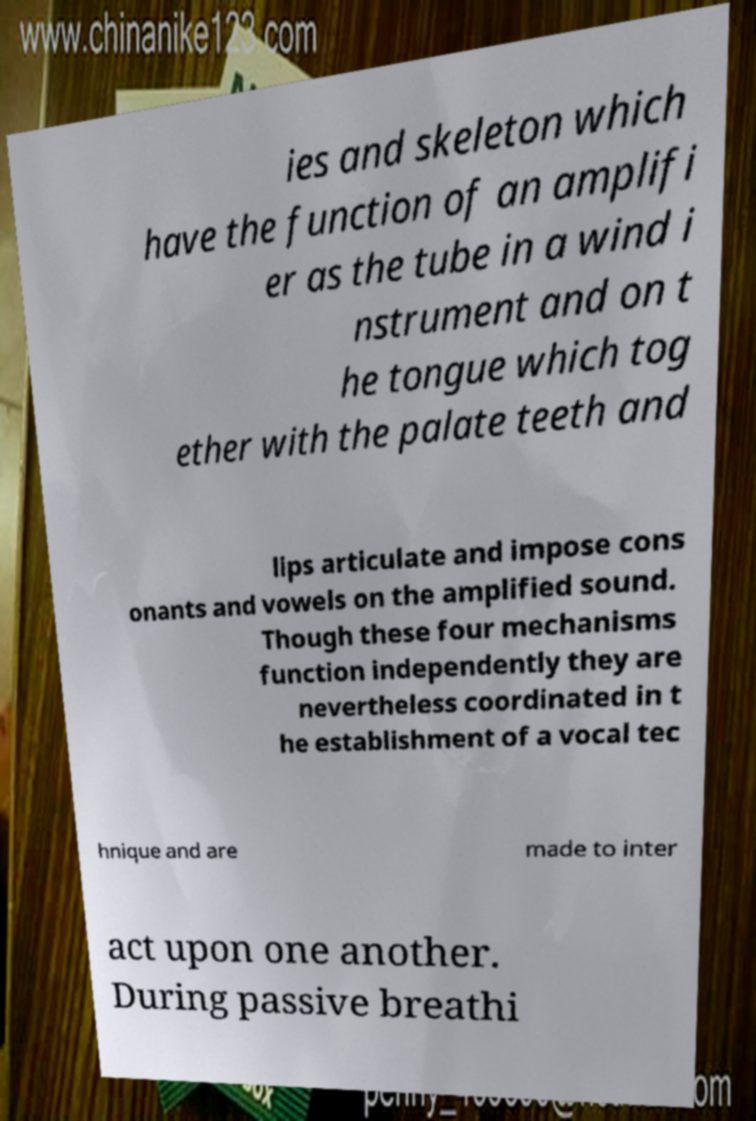Could you extract and type out the text from this image? ies and skeleton which have the function of an amplifi er as the tube in a wind i nstrument and on t he tongue which tog ether with the palate teeth and lips articulate and impose cons onants and vowels on the amplified sound. Though these four mechanisms function independently they are nevertheless coordinated in t he establishment of a vocal tec hnique and are made to inter act upon one another. During passive breathi 